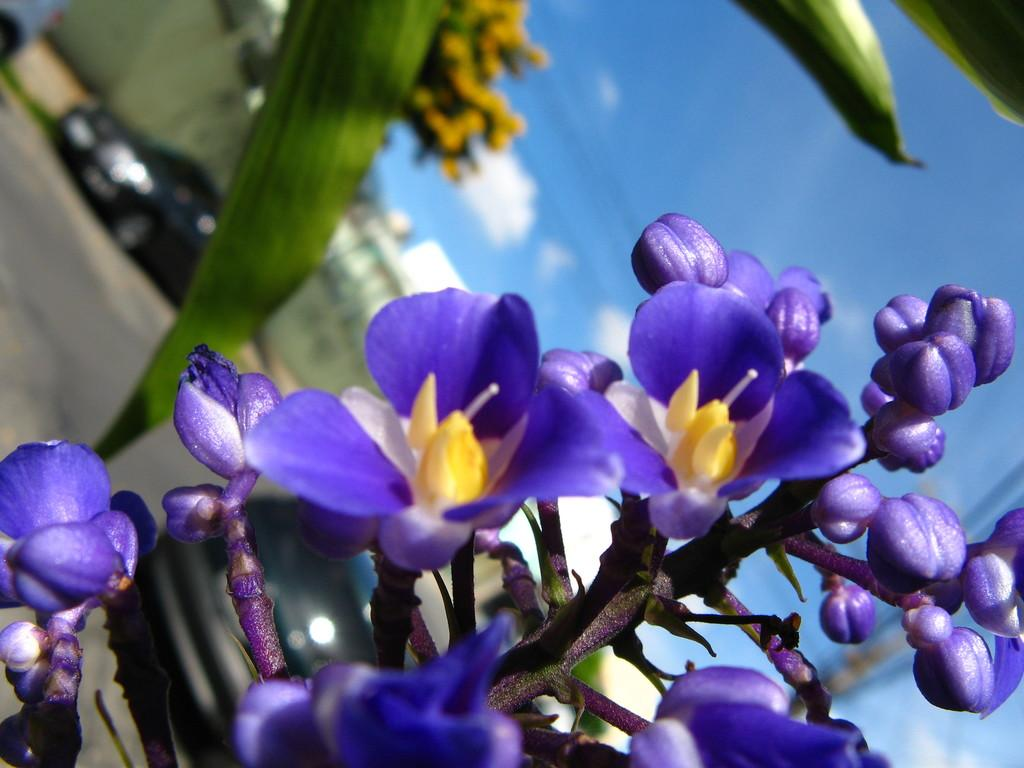What type of plant is visible in the image? There are flowers on a plant in the image. What can be seen in the background of the image? There are motor vehicles on the road and buildings in the background of the image. What is visible in the sky in the image? The sky is visible in the background of the image, and clouds are present. What type of cushion is used to support the scent in the image? There is no cushion or scent present in the image. 